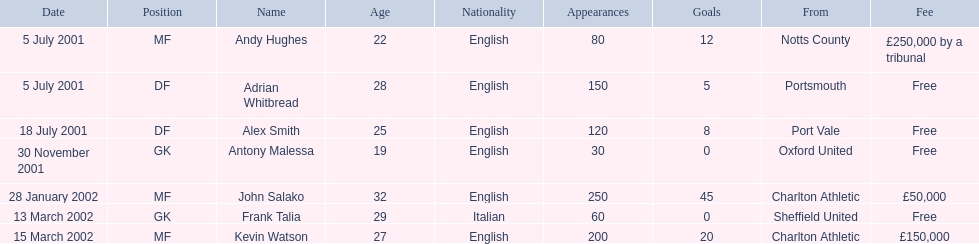What are the names of all the players? Andy Hughes, Adrian Whitbread, Alex Smith, Antony Malessa, John Salako, Frank Talia, Kevin Watson. What fee did andy hughes command? £250,000 by a tribunal. What fee did john salako command? £50,000. Which player had the highest fee, andy hughes or john salako? Andy Hughes. 